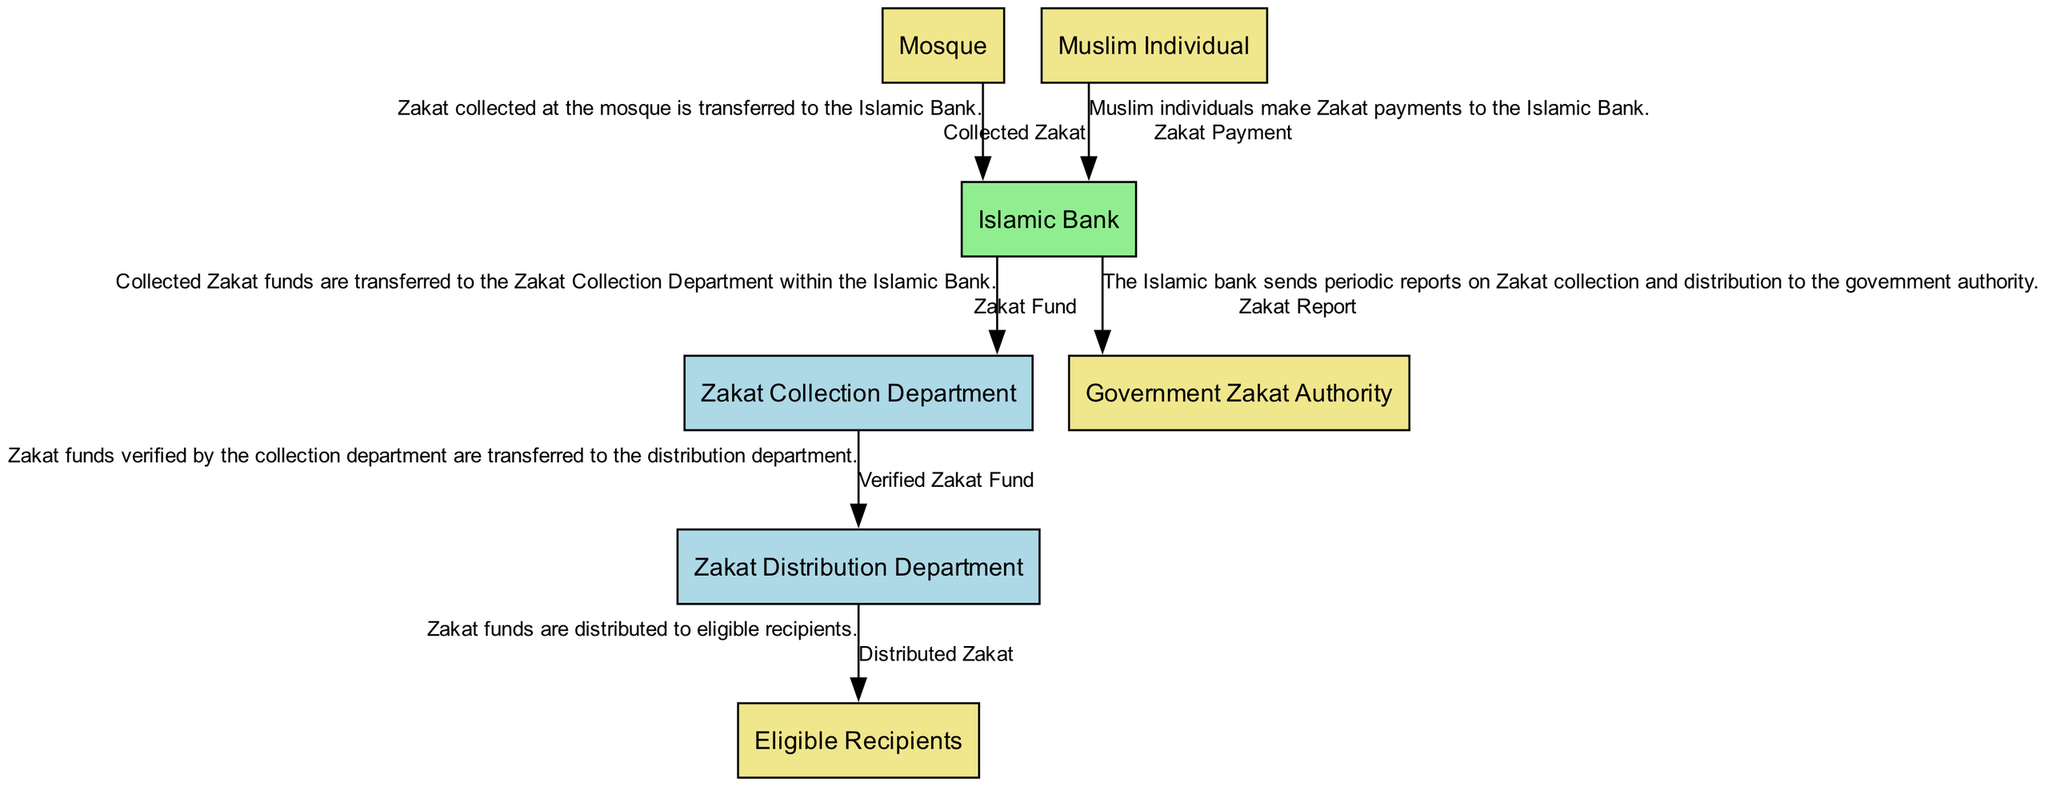What is the main process involved in the Zakat system? The diagram depicts the "Islamic Bank" as the main process handling the collection and distribution of Zakat. It acts as the central node connecting various entities and data flows.
Answer: Islamic Bank How many external entities are present in the diagram? The diagram shows four external entities: "Mosque", "Muslim Individual", "Eligible Recipients", and "Government Zakat Authority". Counting these entities gives a total of four.
Answer: 4 Which department transfers the verified Zakat fund to the distribution department? According to the data flow, the "Zakat Collection Department" is responsible for transferring the "Verified Zakat Fund" to the "Zakat Distribution Department".
Answer: Zakat Collection Department What data do Muslim individuals provide to the Islamic Bank? The data flow indicates that "Muslim Individuals" make "Zakat Payment" to the "Islamic Bank". This clearly states the information exchanged between these entities.
Answer: Zakat Payment What kind of report does the Islamic Bank send to the Government Zakat Authority? The diagram specifies that the "Islamic Bank" sends a "Zakat Report" to the "Government Zakat Authority", outlining the details of Zakat collection and distribution.
Answer: Zakat Report Who receives the distributed Zakat funds? The data flow describes that the final destination of the "Distributed Zakat" is the "Eligible Recipients", who are the individuals or groups entitled to receive Zakat.
Answer: Eligible Recipients Which department is specifically responsible for collecting Zakat? In the diagram, the "Zakat Collection Department" is explicitly stated as the department within the Islamic Bank which is dedicated to the task of collecting Zakat.
Answer: Zakat Collection Department What is transferred from the Mosque to the Islamic Bank? The flow indicates that the "Collected Zakat" from the "Mosque" is transferred to the "Islamic Bank", indicating the movement of Zakat collected at the mosque.
Answer: Collected Zakat How does the Zakat fund flow from the collection department to the distribution department? The flow is displayed as the "Zakat Collection Department" transferring the "Verified Zakat Fund" to the "Zakat Distribution Department", illustrating the sequential movement of funds between these two departments.
Answer: Verified Zakat Fund 